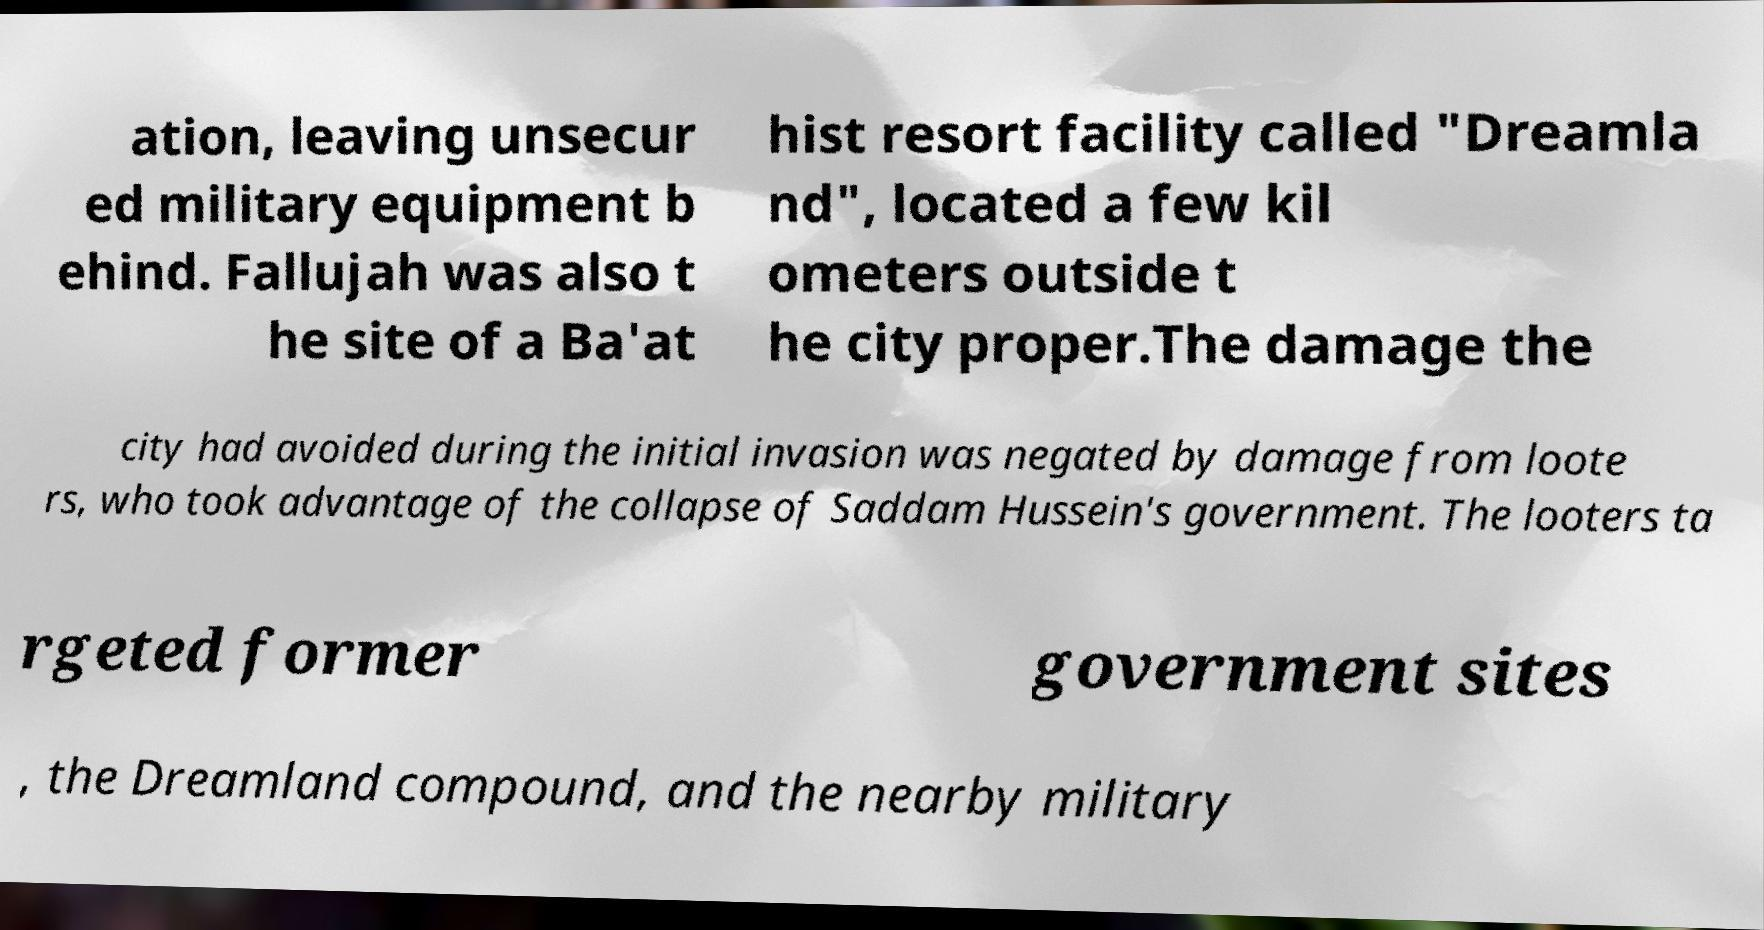What messages or text are displayed in this image? I need them in a readable, typed format. ation, leaving unsecur ed military equipment b ehind. Fallujah was also t he site of a Ba'at hist resort facility called "Dreamla nd", located a few kil ometers outside t he city proper.The damage the city had avoided during the initial invasion was negated by damage from loote rs, who took advantage of the collapse of Saddam Hussein's government. The looters ta rgeted former government sites , the Dreamland compound, and the nearby military 